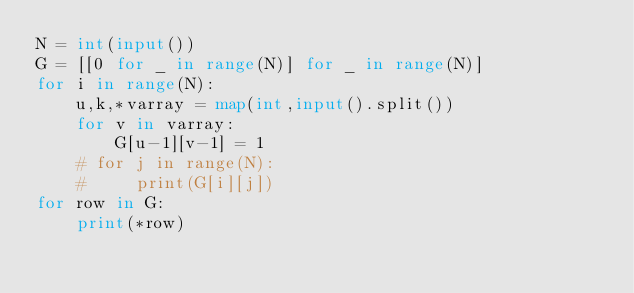<code> <loc_0><loc_0><loc_500><loc_500><_Python_>N = int(input())
G = [[0 for _ in range(N)] for _ in range(N)]
for i in range(N):
    u,k,*varray = map(int,input().split())
    for v in varray:
        G[u-1][v-1] = 1
    # for j in range(N):
    #     print(G[i][j])
for row in G:
    print(*row)
</code> 